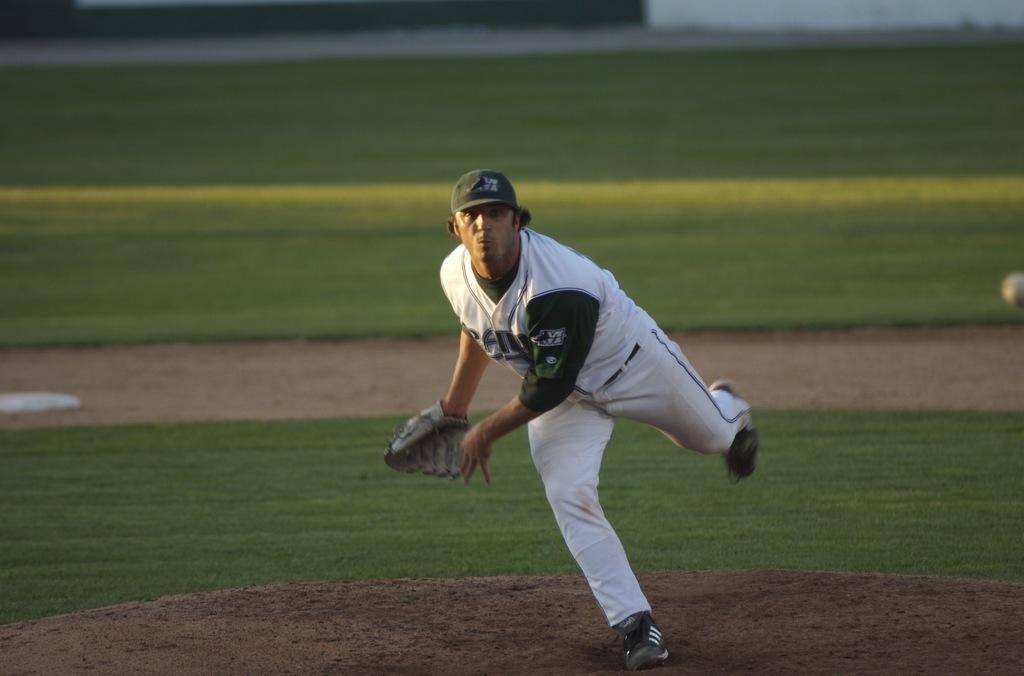Describe this image in one or two sentences. In the image a man is standing. Behind him there is grass. 